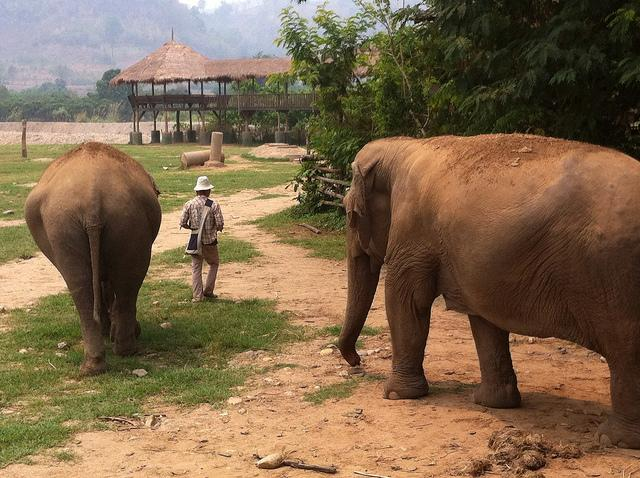What is between the elephants?

Choices:
A) buzzard
B) box
C) bench
D) man man 